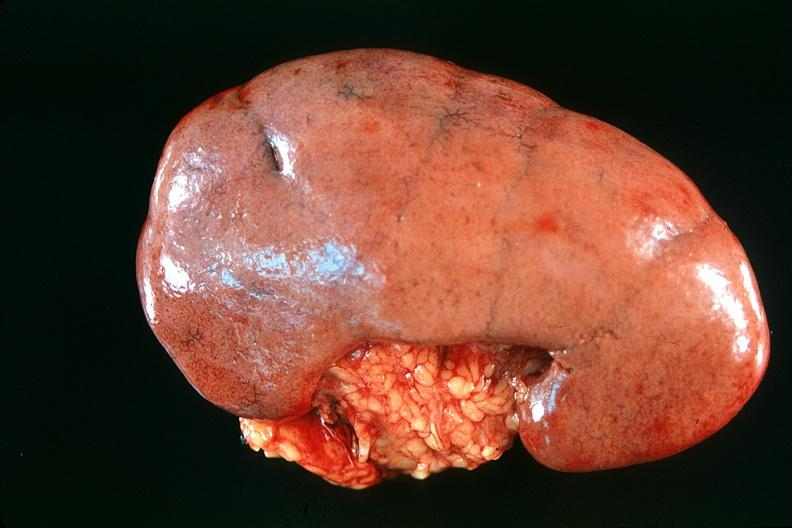what does this image show?
Answer the question using a single word or phrase. Normal kidney 